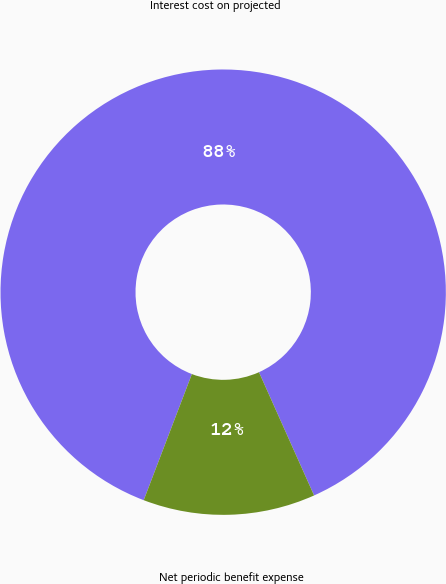Convert chart. <chart><loc_0><loc_0><loc_500><loc_500><pie_chart><fcel>Interest cost on projected<fcel>Net periodic benefit expense<nl><fcel>87.5%<fcel>12.5%<nl></chart> 